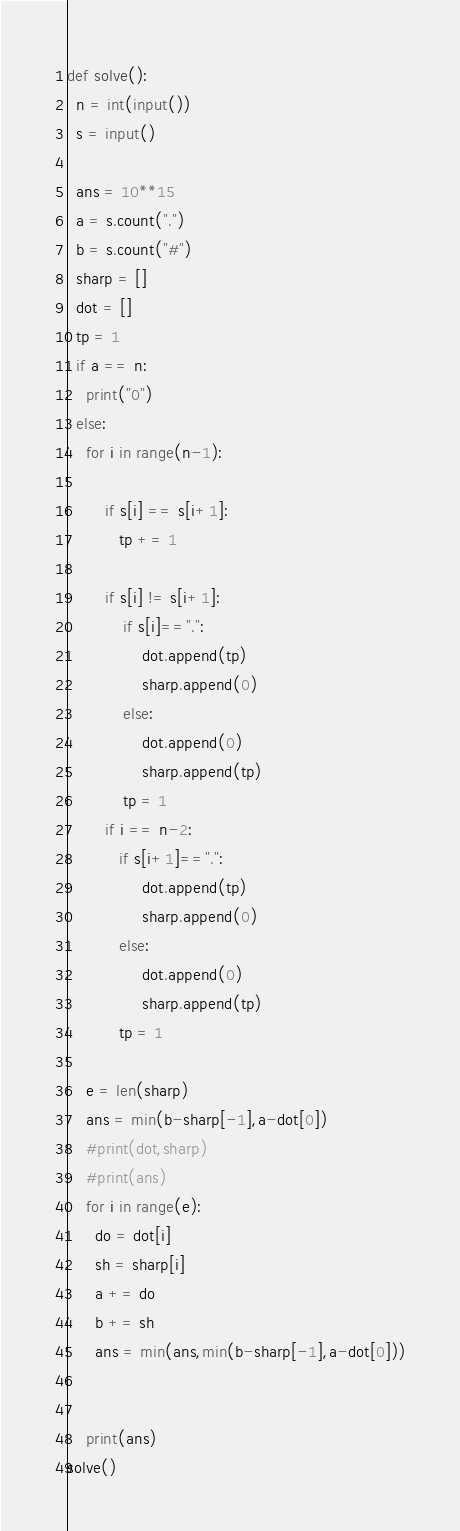<code> <loc_0><loc_0><loc_500><loc_500><_Python_>def solve():
  n = int(input())
  s = input()

  ans = 10**15
  a = s.count(".")
  b = s.count("#")
  sharp = []
  dot = []
  tp = 1
  if a == n:
    print("0")
  else:
    for i in range(n-1):

        if s[i] == s[i+1]:
           tp += 1
               
        if s[i] != s[i+1]:
            if s[i]==".":
                dot.append(tp)
                sharp.append(0)
            else:
                dot.append(0)
                sharp.append(tp)
            tp = 1
        if i == n-2:
           if s[i+1]==".":
                dot.append(tp)
                sharp.append(0)
           else:
                dot.append(0)
                sharp.append(tp)
           tp = 1
    
    e = len(sharp)
    ans = min(b-sharp[-1],a-dot[0])
    #print(dot,sharp)
    #print(ans)
    for i in range(e):
      do = dot[i]
      sh = sharp[i]
      a += do
      b += sh
      ans = min(ans,min(b-sharp[-1],a-dot[0]))
      
        
    print(ans)
solve()</code> 